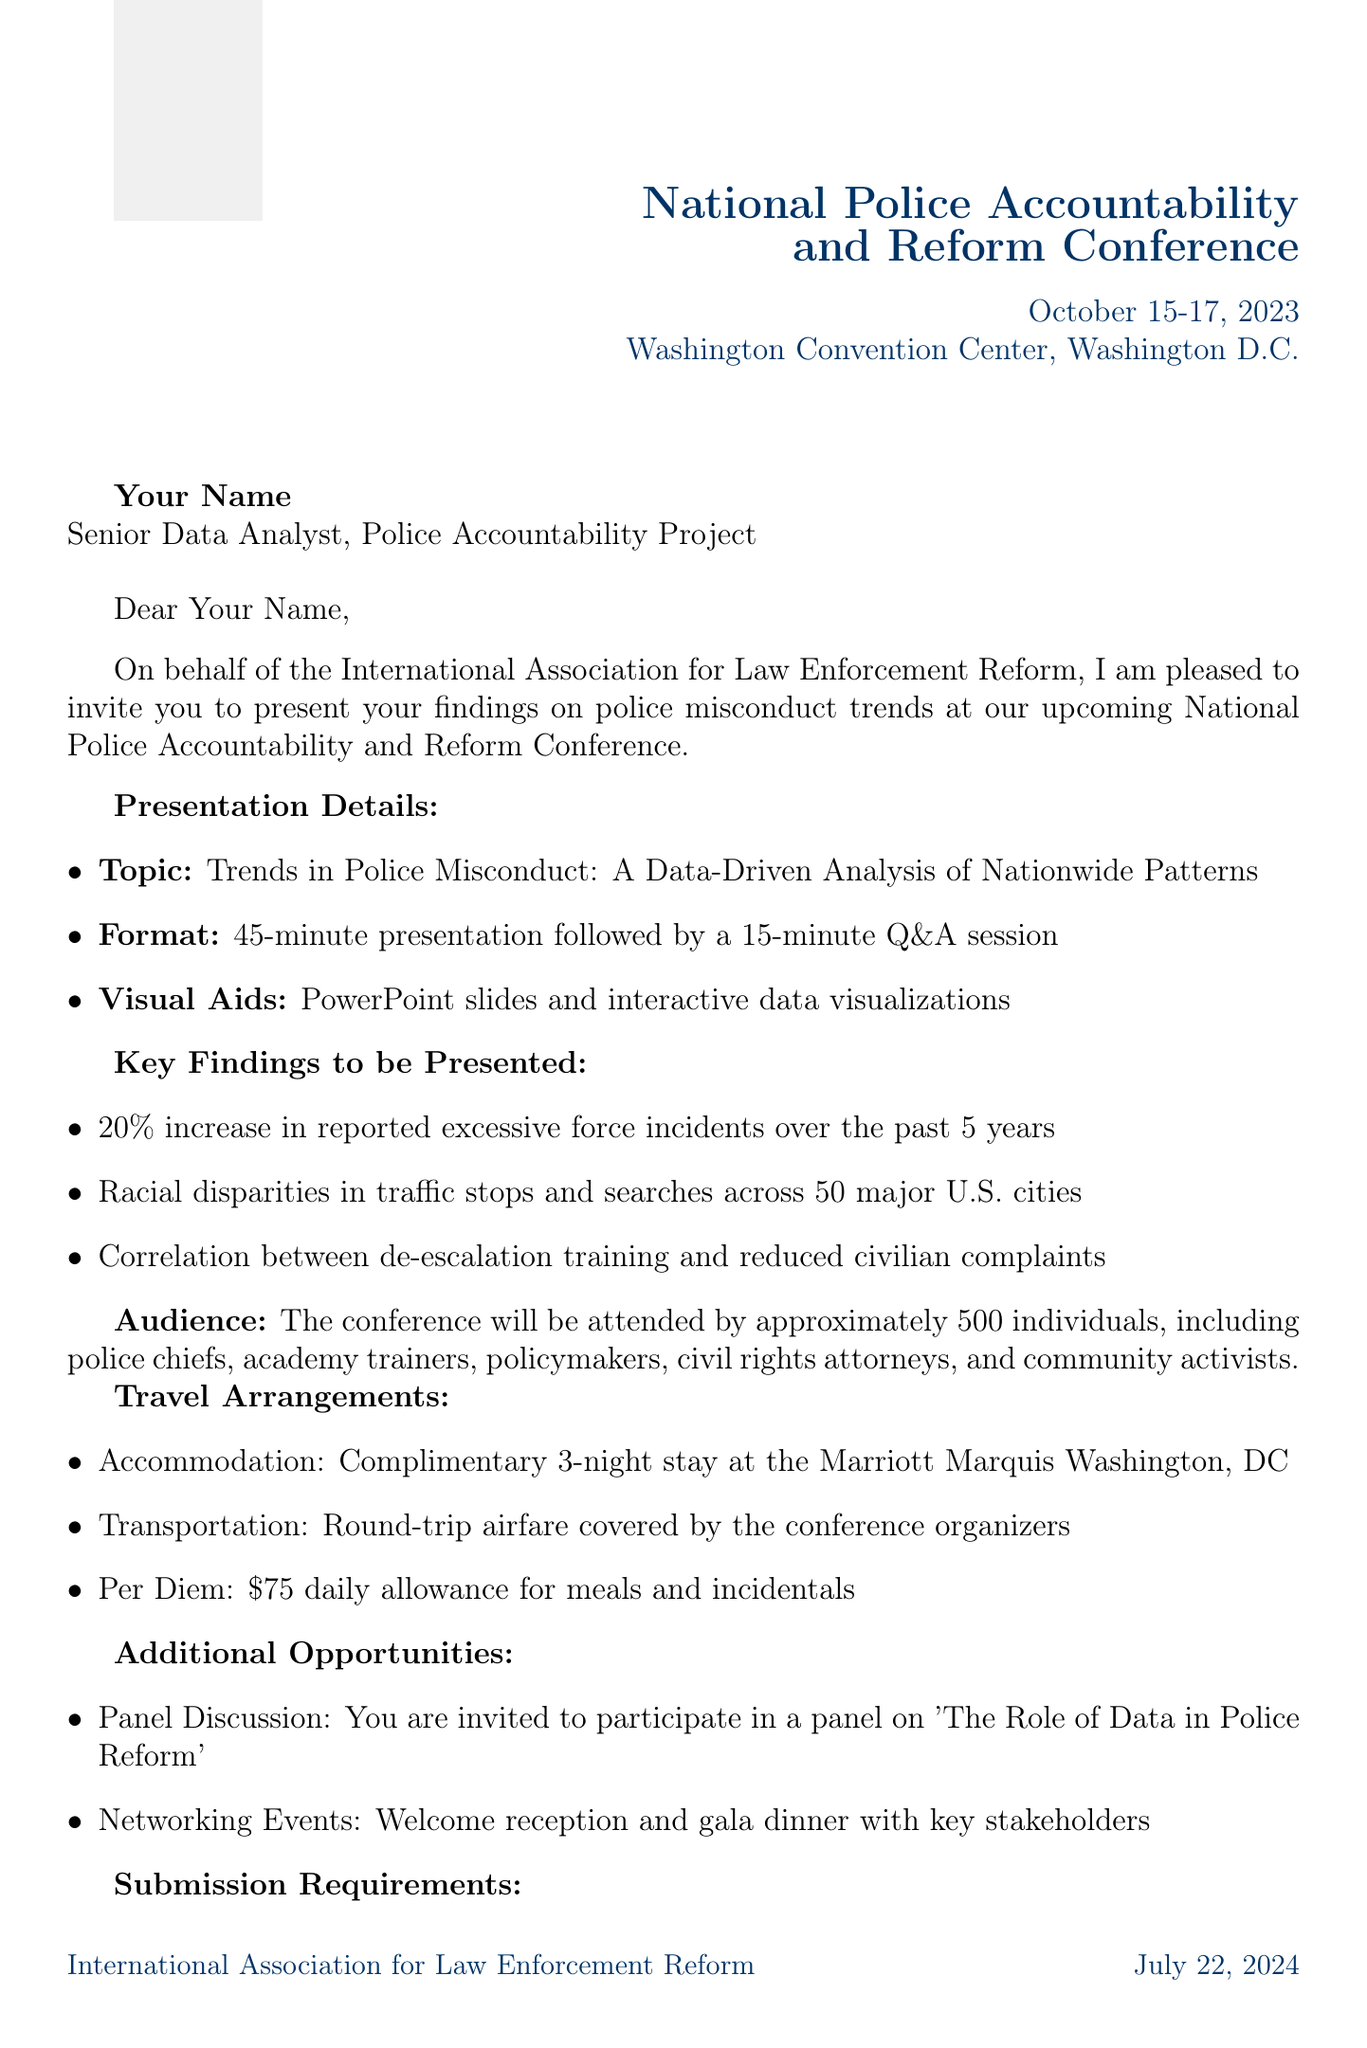What is the name of the conference? The name of the conference is clearly stated in the document, which is "National Police Accountability and Reform Conference."
Answer: National Police Accountability and Reform Conference Who is the sender of the invitation? The document outlines who is sending the invitation, and it is "Dr. Samantha Reeves."
Answer: Dr. Samantha Reeves What is the duration of the presentation? The duration of the presentation is specified in the document as "45-minute presentation."
Answer: 45-minute presentation When is the deadline for submission requirements? The document provides a specific date for the deadline, which is "August 1, 2023."
Answer: August 1, 2023 What percentage increase in excessive force incidents is noted in the findings? The key findings section of the document states a "20% increase" in reported excessive force incidents over the past 5 years.
Answer: 20% What type of professionals will be part of the audience? The document mentions multiple roles among the audience, such as "police chiefs and high-ranking officers."
Answer: police chiefs and high-ranking officers What kind of accommodation is provided to the presenter? The document specifies the type of accommodation, which is a "complimentary 3-night stay at the Marriott Marquis Washington, DC."
Answer: complimentary 3-night stay at the Marriott Marquis Washington, DC What additional opportunity is mentioned apart from the presentation? An additional opportunity mentioned in the document is participation in a "panel on 'The Role of Data in Police Reform'."
Answer: panel on 'The Role of Data in Police Reform' What is the estimated size of the audience? The document estimates the size of the audience to be "approximately 500 individuals."
Answer: approximately 500 individuals 